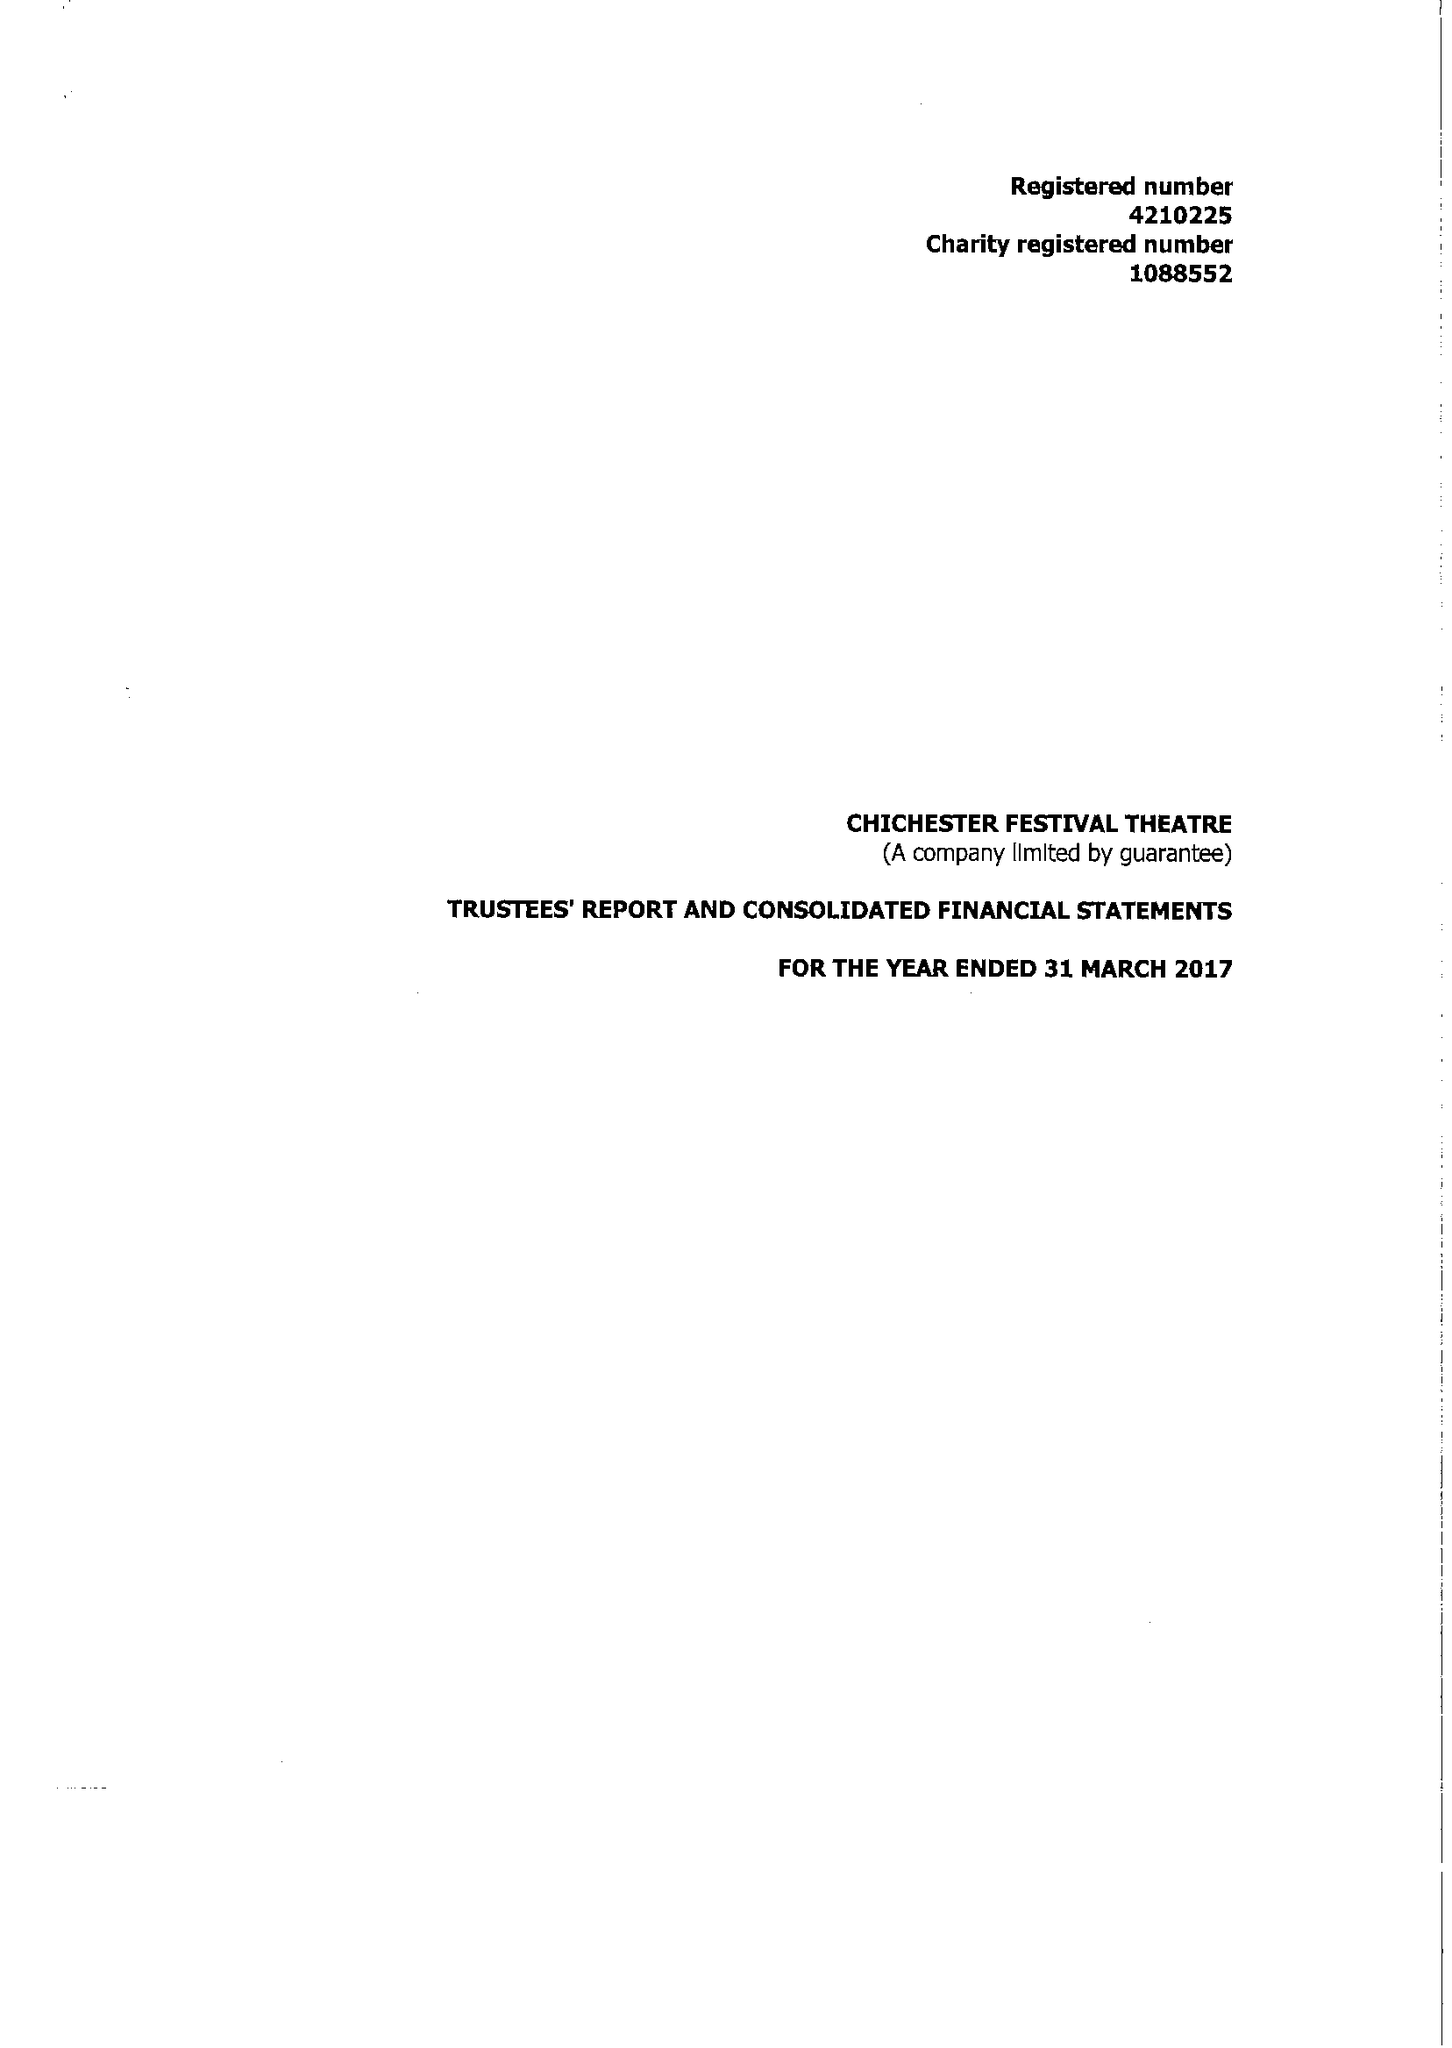What is the value for the charity_name?
Answer the question using a single word or phrase. Chichester Festival Theatre 